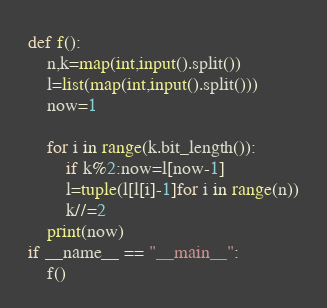<code> <loc_0><loc_0><loc_500><loc_500><_Python_>def f():
    n,k=map(int,input().split())
    l=list(map(int,input().split()))
    now=1

    for i in range(k.bit_length()):
        if k%2:now=l[now-1]
        l=tuple(l[l[i]-1]for i in range(n))
        k//=2
    print(now)
if __name__ == "__main__":
    f()</code> 